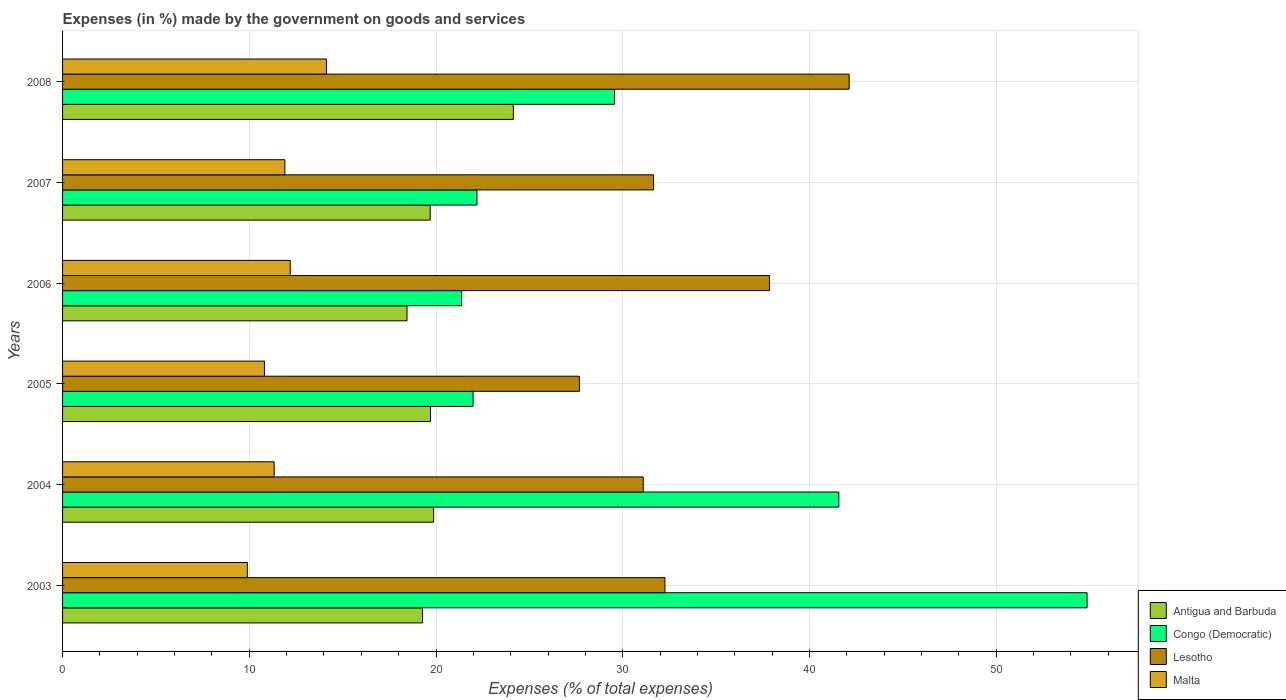How many different coloured bars are there?
Make the answer very short. 4. Are the number of bars per tick equal to the number of legend labels?
Your response must be concise. Yes. Are the number of bars on each tick of the Y-axis equal?
Your answer should be compact. Yes. In how many cases, is the number of bars for a given year not equal to the number of legend labels?
Keep it short and to the point. 0. What is the percentage of expenses made by the government on goods and services in Congo (Democratic) in 2006?
Keep it short and to the point. 21.37. Across all years, what is the maximum percentage of expenses made by the government on goods and services in Congo (Democratic)?
Ensure brevity in your answer.  54.87. Across all years, what is the minimum percentage of expenses made by the government on goods and services in Antigua and Barbuda?
Your response must be concise. 18.45. What is the total percentage of expenses made by the government on goods and services in Antigua and Barbuda in the graph?
Offer a very short reply. 121.14. What is the difference between the percentage of expenses made by the government on goods and services in Lesotho in 2007 and that in 2008?
Your answer should be very brief. -10.47. What is the difference between the percentage of expenses made by the government on goods and services in Malta in 2005 and the percentage of expenses made by the government on goods and services in Lesotho in 2008?
Your answer should be compact. -31.32. What is the average percentage of expenses made by the government on goods and services in Lesotho per year?
Provide a short and direct response. 33.78. In the year 2003, what is the difference between the percentage of expenses made by the government on goods and services in Antigua and Barbuda and percentage of expenses made by the government on goods and services in Lesotho?
Ensure brevity in your answer.  -12.98. In how many years, is the percentage of expenses made by the government on goods and services in Congo (Democratic) greater than 38 %?
Provide a short and direct response. 2. What is the ratio of the percentage of expenses made by the government on goods and services in Malta in 2005 to that in 2008?
Provide a short and direct response. 0.77. What is the difference between the highest and the second highest percentage of expenses made by the government on goods and services in Lesotho?
Make the answer very short. 4.26. What is the difference between the highest and the lowest percentage of expenses made by the government on goods and services in Congo (Democratic)?
Offer a very short reply. 33.5. In how many years, is the percentage of expenses made by the government on goods and services in Antigua and Barbuda greater than the average percentage of expenses made by the government on goods and services in Antigua and Barbuda taken over all years?
Make the answer very short. 1. Is the sum of the percentage of expenses made by the government on goods and services in Malta in 2004 and 2008 greater than the maximum percentage of expenses made by the government on goods and services in Lesotho across all years?
Make the answer very short. No. Is it the case that in every year, the sum of the percentage of expenses made by the government on goods and services in Lesotho and percentage of expenses made by the government on goods and services in Malta is greater than the sum of percentage of expenses made by the government on goods and services in Congo (Democratic) and percentage of expenses made by the government on goods and services in Antigua and Barbuda?
Make the answer very short. No. What does the 2nd bar from the top in 2007 represents?
Your answer should be compact. Lesotho. What does the 4th bar from the bottom in 2004 represents?
Your response must be concise. Malta. How many bars are there?
Give a very brief answer. 24. Are all the bars in the graph horizontal?
Give a very brief answer. Yes. How many years are there in the graph?
Your answer should be compact. 6. What is the difference between two consecutive major ticks on the X-axis?
Offer a terse response. 10. Are the values on the major ticks of X-axis written in scientific E-notation?
Provide a short and direct response. No. Does the graph contain any zero values?
Make the answer very short. No. Does the graph contain grids?
Offer a very short reply. Yes. How many legend labels are there?
Keep it short and to the point. 4. How are the legend labels stacked?
Offer a very short reply. Vertical. What is the title of the graph?
Keep it short and to the point. Expenses (in %) made by the government on goods and services. Does "European Union" appear as one of the legend labels in the graph?
Your answer should be compact. No. What is the label or title of the X-axis?
Offer a very short reply. Expenses (% of total expenses). What is the Expenses (% of total expenses) in Antigua and Barbuda in 2003?
Your answer should be compact. 19.28. What is the Expenses (% of total expenses) in Congo (Democratic) in 2003?
Your response must be concise. 54.87. What is the Expenses (% of total expenses) of Lesotho in 2003?
Keep it short and to the point. 32.26. What is the Expenses (% of total expenses) of Malta in 2003?
Your answer should be compact. 9.89. What is the Expenses (% of total expenses) in Antigua and Barbuda in 2004?
Provide a succinct answer. 19.87. What is the Expenses (% of total expenses) of Congo (Democratic) in 2004?
Offer a very short reply. 41.57. What is the Expenses (% of total expenses) of Lesotho in 2004?
Give a very brief answer. 31.1. What is the Expenses (% of total expenses) in Malta in 2004?
Offer a terse response. 11.33. What is the Expenses (% of total expenses) of Antigua and Barbuda in 2005?
Your answer should be very brief. 19.71. What is the Expenses (% of total expenses) in Congo (Democratic) in 2005?
Provide a succinct answer. 21.99. What is the Expenses (% of total expenses) in Lesotho in 2005?
Provide a short and direct response. 27.68. What is the Expenses (% of total expenses) in Malta in 2005?
Offer a terse response. 10.81. What is the Expenses (% of total expenses) in Antigua and Barbuda in 2006?
Offer a terse response. 18.45. What is the Expenses (% of total expenses) in Congo (Democratic) in 2006?
Ensure brevity in your answer.  21.37. What is the Expenses (% of total expenses) of Lesotho in 2006?
Make the answer very short. 37.86. What is the Expenses (% of total expenses) in Malta in 2006?
Ensure brevity in your answer.  12.19. What is the Expenses (% of total expenses) in Antigua and Barbuda in 2007?
Your response must be concise. 19.69. What is the Expenses (% of total expenses) of Congo (Democratic) in 2007?
Offer a very short reply. 22.19. What is the Expenses (% of total expenses) in Lesotho in 2007?
Your response must be concise. 31.65. What is the Expenses (% of total expenses) in Malta in 2007?
Your answer should be compact. 11.91. What is the Expenses (% of total expenses) of Antigua and Barbuda in 2008?
Offer a terse response. 24.14. What is the Expenses (% of total expenses) in Congo (Democratic) in 2008?
Your response must be concise. 29.56. What is the Expenses (% of total expenses) in Lesotho in 2008?
Your answer should be compact. 42.13. What is the Expenses (% of total expenses) in Malta in 2008?
Offer a very short reply. 14.13. Across all years, what is the maximum Expenses (% of total expenses) of Antigua and Barbuda?
Offer a terse response. 24.14. Across all years, what is the maximum Expenses (% of total expenses) in Congo (Democratic)?
Make the answer very short. 54.87. Across all years, what is the maximum Expenses (% of total expenses) of Lesotho?
Provide a succinct answer. 42.13. Across all years, what is the maximum Expenses (% of total expenses) in Malta?
Provide a succinct answer. 14.13. Across all years, what is the minimum Expenses (% of total expenses) in Antigua and Barbuda?
Provide a short and direct response. 18.45. Across all years, what is the minimum Expenses (% of total expenses) in Congo (Democratic)?
Keep it short and to the point. 21.37. Across all years, what is the minimum Expenses (% of total expenses) of Lesotho?
Make the answer very short. 27.68. Across all years, what is the minimum Expenses (% of total expenses) of Malta?
Keep it short and to the point. 9.89. What is the total Expenses (% of total expenses) in Antigua and Barbuda in the graph?
Offer a very short reply. 121.14. What is the total Expenses (% of total expenses) of Congo (Democratic) in the graph?
Provide a short and direct response. 191.55. What is the total Expenses (% of total expenses) of Lesotho in the graph?
Your response must be concise. 202.68. What is the total Expenses (% of total expenses) of Malta in the graph?
Make the answer very short. 70.27. What is the difference between the Expenses (% of total expenses) in Antigua and Barbuda in 2003 and that in 2004?
Your answer should be compact. -0.59. What is the difference between the Expenses (% of total expenses) of Congo (Democratic) in 2003 and that in 2004?
Your response must be concise. 13.29. What is the difference between the Expenses (% of total expenses) of Lesotho in 2003 and that in 2004?
Give a very brief answer. 1.16. What is the difference between the Expenses (% of total expenses) of Malta in 2003 and that in 2004?
Make the answer very short. -1.44. What is the difference between the Expenses (% of total expenses) of Antigua and Barbuda in 2003 and that in 2005?
Make the answer very short. -0.43. What is the difference between the Expenses (% of total expenses) of Congo (Democratic) in 2003 and that in 2005?
Keep it short and to the point. 32.88. What is the difference between the Expenses (% of total expenses) in Lesotho in 2003 and that in 2005?
Your response must be concise. 4.58. What is the difference between the Expenses (% of total expenses) in Malta in 2003 and that in 2005?
Offer a terse response. -0.92. What is the difference between the Expenses (% of total expenses) in Antigua and Barbuda in 2003 and that in 2006?
Make the answer very short. 0.83. What is the difference between the Expenses (% of total expenses) of Congo (Democratic) in 2003 and that in 2006?
Ensure brevity in your answer.  33.5. What is the difference between the Expenses (% of total expenses) of Lesotho in 2003 and that in 2006?
Make the answer very short. -5.6. What is the difference between the Expenses (% of total expenses) of Malta in 2003 and that in 2006?
Provide a succinct answer. -2.3. What is the difference between the Expenses (% of total expenses) in Antigua and Barbuda in 2003 and that in 2007?
Make the answer very short. -0.41. What is the difference between the Expenses (% of total expenses) in Congo (Democratic) in 2003 and that in 2007?
Offer a very short reply. 32.67. What is the difference between the Expenses (% of total expenses) in Lesotho in 2003 and that in 2007?
Make the answer very short. 0.61. What is the difference between the Expenses (% of total expenses) of Malta in 2003 and that in 2007?
Keep it short and to the point. -2.01. What is the difference between the Expenses (% of total expenses) in Antigua and Barbuda in 2003 and that in 2008?
Your answer should be very brief. -4.86. What is the difference between the Expenses (% of total expenses) of Congo (Democratic) in 2003 and that in 2008?
Your answer should be compact. 25.31. What is the difference between the Expenses (% of total expenses) in Lesotho in 2003 and that in 2008?
Offer a terse response. -9.87. What is the difference between the Expenses (% of total expenses) in Malta in 2003 and that in 2008?
Your answer should be very brief. -4.24. What is the difference between the Expenses (% of total expenses) in Antigua and Barbuda in 2004 and that in 2005?
Give a very brief answer. 0.17. What is the difference between the Expenses (% of total expenses) in Congo (Democratic) in 2004 and that in 2005?
Provide a short and direct response. 19.59. What is the difference between the Expenses (% of total expenses) in Lesotho in 2004 and that in 2005?
Make the answer very short. 3.42. What is the difference between the Expenses (% of total expenses) of Malta in 2004 and that in 2005?
Offer a terse response. 0.52. What is the difference between the Expenses (% of total expenses) in Antigua and Barbuda in 2004 and that in 2006?
Provide a succinct answer. 1.43. What is the difference between the Expenses (% of total expenses) of Congo (Democratic) in 2004 and that in 2006?
Provide a succinct answer. 20.2. What is the difference between the Expenses (% of total expenses) of Lesotho in 2004 and that in 2006?
Make the answer very short. -6.77. What is the difference between the Expenses (% of total expenses) of Malta in 2004 and that in 2006?
Ensure brevity in your answer.  -0.86. What is the difference between the Expenses (% of total expenses) in Antigua and Barbuda in 2004 and that in 2007?
Keep it short and to the point. 0.18. What is the difference between the Expenses (% of total expenses) of Congo (Democratic) in 2004 and that in 2007?
Keep it short and to the point. 19.38. What is the difference between the Expenses (% of total expenses) of Lesotho in 2004 and that in 2007?
Your answer should be compact. -0.56. What is the difference between the Expenses (% of total expenses) of Malta in 2004 and that in 2007?
Give a very brief answer. -0.57. What is the difference between the Expenses (% of total expenses) in Antigua and Barbuda in 2004 and that in 2008?
Your answer should be compact. -4.27. What is the difference between the Expenses (% of total expenses) in Congo (Democratic) in 2004 and that in 2008?
Make the answer very short. 12.01. What is the difference between the Expenses (% of total expenses) of Lesotho in 2004 and that in 2008?
Offer a very short reply. -11.03. What is the difference between the Expenses (% of total expenses) in Malta in 2004 and that in 2008?
Ensure brevity in your answer.  -2.8. What is the difference between the Expenses (% of total expenses) of Antigua and Barbuda in 2005 and that in 2006?
Your response must be concise. 1.26. What is the difference between the Expenses (% of total expenses) in Congo (Democratic) in 2005 and that in 2006?
Provide a short and direct response. 0.61. What is the difference between the Expenses (% of total expenses) in Lesotho in 2005 and that in 2006?
Your answer should be very brief. -10.18. What is the difference between the Expenses (% of total expenses) of Malta in 2005 and that in 2006?
Give a very brief answer. -1.38. What is the difference between the Expenses (% of total expenses) in Antigua and Barbuda in 2005 and that in 2007?
Offer a very short reply. 0.01. What is the difference between the Expenses (% of total expenses) of Congo (Democratic) in 2005 and that in 2007?
Your response must be concise. -0.21. What is the difference between the Expenses (% of total expenses) in Lesotho in 2005 and that in 2007?
Keep it short and to the point. -3.97. What is the difference between the Expenses (% of total expenses) of Malta in 2005 and that in 2007?
Give a very brief answer. -1.09. What is the difference between the Expenses (% of total expenses) of Antigua and Barbuda in 2005 and that in 2008?
Provide a short and direct response. -4.44. What is the difference between the Expenses (% of total expenses) in Congo (Democratic) in 2005 and that in 2008?
Offer a terse response. -7.58. What is the difference between the Expenses (% of total expenses) in Lesotho in 2005 and that in 2008?
Your answer should be very brief. -14.45. What is the difference between the Expenses (% of total expenses) of Malta in 2005 and that in 2008?
Your response must be concise. -3.32. What is the difference between the Expenses (% of total expenses) in Antigua and Barbuda in 2006 and that in 2007?
Your response must be concise. -1.24. What is the difference between the Expenses (% of total expenses) in Congo (Democratic) in 2006 and that in 2007?
Give a very brief answer. -0.82. What is the difference between the Expenses (% of total expenses) of Lesotho in 2006 and that in 2007?
Give a very brief answer. 6.21. What is the difference between the Expenses (% of total expenses) of Malta in 2006 and that in 2007?
Provide a short and direct response. 0.29. What is the difference between the Expenses (% of total expenses) of Antigua and Barbuda in 2006 and that in 2008?
Give a very brief answer. -5.69. What is the difference between the Expenses (% of total expenses) in Congo (Democratic) in 2006 and that in 2008?
Keep it short and to the point. -8.19. What is the difference between the Expenses (% of total expenses) in Lesotho in 2006 and that in 2008?
Your answer should be compact. -4.26. What is the difference between the Expenses (% of total expenses) of Malta in 2006 and that in 2008?
Offer a terse response. -1.94. What is the difference between the Expenses (% of total expenses) in Antigua and Barbuda in 2007 and that in 2008?
Provide a succinct answer. -4.45. What is the difference between the Expenses (% of total expenses) in Congo (Democratic) in 2007 and that in 2008?
Your answer should be very brief. -7.37. What is the difference between the Expenses (% of total expenses) of Lesotho in 2007 and that in 2008?
Offer a terse response. -10.47. What is the difference between the Expenses (% of total expenses) of Malta in 2007 and that in 2008?
Provide a succinct answer. -2.23. What is the difference between the Expenses (% of total expenses) in Antigua and Barbuda in 2003 and the Expenses (% of total expenses) in Congo (Democratic) in 2004?
Make the answer very short. -22.29. What is the difference between the Expenses (% of total expenses) in Antigua and Barbuda in 2003 and the Expenses (% of total expenses) in Lesotho in 2004?
Provide a succinct answer. -11.82. What is the difference between the Expenses (% of total expenses) in Antigua and Barbuda in 2003 and the Expenses (% of total expenses) in Malta in 2004?
Your response must be concise. 7.95. What is the difference between the Expenses (% of total expenses) of Congo (Democratic) in 2003 and the Expenses (% of total expenses) of Lesotho in 2004?
Your response must be concise. 23.77. What is the difference between the Expenses (% of total expenses) in Congo (Democratic) in 2003 and the Expenses (% of total expenses) in Malta in 2004?
Make the answer very short. 43.54. What is the difference between the Expenses (% of total expenses) in Lesotho in 2003 and the Expenses (% of total expenses) in Malta in 2004?
Give a very brief answer. 20.93. What is the difference between the Expenses (% of total expenses) in Antigua and Barbuda in 2003 and the Expenses (% of total expenses) in Congo (Democratic) in 2005?
Give a very brief answer. -2.71. What is the difference between the Expenses (% of total expenses) in Antigua and Barbuda in 2003 and the Expenses (% of total expenses) in Lesotho in 2005?
Keep it short and to the point. -8.4. What is the difference between the Expenses (% of total expenses) of Antigua and Barbuda in 2003 and the Expenses (% of total expenses) of Malta in 2005?
Make the answer very short. 8.47. What is the difference between the Expenses (% of total expenses) in Congo (Democratic) in 2003 and the Expenses (% of total expenses) in Lesotho in 2005?
Offer a terse response. 27.19. What is the difference between the Expenses (% of total expenses) in Congo (Democratic) in 2003 and the Expenses (% of total expenses) in Malta in 2005?
Make the answer very short. 44.06. What is the difference between the Expenses (% of total expenses) in Lesotho in 2003 and the Expenses (% of total expenses) in Malta in 2005?
Provide a succinct answer. 21.45. What is the difference between the Expenses (% of total expenses) in Antigua and Barbuda in 2003 and the Expenses (% of total expenses) in Congo (Democratic) in 2006?
Give a very brief answer. -2.09. What is the difference between the Expenses (% of total expenses) of Antigua and Barbuda in 2003 and the Expenses (% of total expenses) of Lesotho in 2006?
Give a very brief answer. -18.58. What is the difference between the Expenses (% of total expenses) of Antigua and Barbuda in 2003 and the Expenses (% of total expenses) of Malta in 2006?
Your response must be concise. 7.09. What is the difference between the Expenses (% of total expenses) of Congo (Democratic) in 2003 and the Expenses (% of total expenses) of Lesotho in 2006?
Offer a terse response. 17.01. What is the difference between the Expenses (% of total expenses) of Congo (Democratic) in 2003 and the Expenses (% of total expenses) of Malta in 2006?
Make the answer very short. 42.67. What is the difference between the Expenses (% of total expenses) of Lesotho in 2003 and the Expenses (% of total expenses) of Malta in 2006?
Provide a short and direct response. 20.07. What is the difference between the Expenses (% of total expenses) of Antigua and Barbuda in 2003 and the Expenses (% of total expenses) of Congo (Democratic) in 2007?
Your response must be concise. -2.91. What is the difference between the Expenses (% of total expenses) of Antigua and Barbuda in 2003 and the Expenses (% of total expenses) of Lesotho in 2007?
Provide a short and direct response. -12.37. What is the difference between the Expenses (% of total expenses) of Antigua and Barbuda in 2003 and the Expenses (% of total expenses) of Malta in 2007?
Offer a very short reply. 7.38. What is the difference between the Expenses (% of total expenses) of Congo (Democratic) in 2003 and the Expenses (% of total expenses) of Lesotho in 2007?
Provide a succinct answer. 23.21. What is the difference between the Expenses (% of total expenses) in Congo (Democratic) in 2003 and the Expenses (% of total expenses) in Malta in 2007?
Ensure brevity in your answer.  42.96. What is the difference between the Expenses (% of total expenses) in Lesotho in 2003 and the Expenses (% of total expenses) in Malta in 2007?
Your response must be concise. 20.36. What is the difference between the Expenses (% of total expenses) in Antigua and Barbuda in 2003 and the Expenses (% of total expenses) in Congo (Democratic) in 2008?
Your answer should be compact. -10.28. What is the difference between the Expenses (% of total expenses) of Antigua and Barbuda in 2003 and the Expenses (% of total expenses) of Lesotho in 2008?
Your response must be concise. -22.85. What is the difference between the Expenses (% of total expenses) of Antigua and Barbuda in 2003 and the Expenses (% of total expenses) of Malta in 2008?
Provide a short and direct response. 5.15. What is the difference between the Expenses (% of total expenses) of Congo (Democratic) in 2003 and the Expenses (% of total expenses) of Lesotho in 2008?
Provide a succinct answer. 12.74. What is the difference between the Expenses (% of total expenses) of Congo (Democratic) in 2003 and the Expenses (% of total expenses) of Malta in 2008?
Provide a succinct answer. 40.74. What is the difference between the Expenses (% of total expenses) in Lesotho in 2003 and the Expenses (% of total expenses) in Malta in 2008?
Provide a succinct answer. 18.13. What is the difference between the Expenses (% of total expenses) in Antigua and Barbuda in 2004 and the Expenses (% of total expenses) in Congo (Democratic) in 2005?
Ensure brevity in your answer.  -2.11. What is the difference between the Expenses (% of total expenses) in Antigua and Barbuda in 2004 and the Expenses (% of total expenses) in Lesotho in 2005?
Offer a terse response. -7.81. What is the difference between the Expenses (% of total expenses) in Antigua and Barbuda in 2004 and the Expenses (% of total expenses) in Malta in 2005?
Provide a short and direct response. 9.06. What is the difference between the Expenses (% of total expenses) in Congo (Democratic) in 2004 and the Expenses (% of total expenses) in Lesotho in 2005?
Your answer should be compact. 13.89. What is the difference between the Expenses (% of total expenses) in Congo (Democratic) in 2004 and the Expenses (% of total expenses) in Malta in 2005?
Your answer should be compact. 30.76. What is the difference between the Expenses (% of total expenses) of Lesotho in 2004 and the Expenses (% of total expenses) of Malta in 2005?
Offer a terse response. 20.29. What is the difference between the Expenses (% of total expenses) of Antigua and Barbuda in 2004 and the Expenses (% of total expenses) of Congo (Democratic) in 2006?
Keep it short and to the point. -1.5. What is the difference between the Expenses (% of total expenses) of Antigua and Barbuda in 2004 and the Expenses (% of total expenses) of Lesotho in 2006?
Offer a very short reply. -17.99. What is the difference between the Expenses (% of total expenses) of Antigua and Barbuda in 2004 and the Expenses (% of total expenses) of Malta in 2006?
Provide a succinct answer. 7.68. What is the difference between the Expenses (% of total expenses) in Congo (Democratic) in 2004 and the Expenses (% of total expenses) in Lesotho in 2006?
Your answer should be compact. 3.71. What is the difference between the Expenses (% of total expenses) of Congo (Democratic) in 2004 and the Expenses (% of total expenses) of Malta in 2006?
Your response must be concise. 29.38. What is the difference between the Expenses (% of total expenses) of Lesotho in 2004 and the Expenses (% of total expenses) of Malta in 2006?
Make the answer very short. 18.9. What is the difference between the Expenses (% of total expenses) in Antigua and Barbuda in 2004 and the Expenses (% of total expenses) in Congo (Democratic) in 2007?
Your response must be concise. -2.32. What is the difference between the Expenses (% of total expenses) in Antigua and Barbuda in 2004 and the Expenses (% of total expenses) in Lesotho in 2007?
Ensure brevity in your answer.  -11.78. What is the difference between the Expenses (% of total expenses) of Antigua and Barbuda in 2004 and the Expenses (% of total expenses) of Malta in 2007?
Offer a very short reply. 7.97. What is the difference between the Expenses (% of total expenses) of Congo (Democratic) in 2004 and the Expenses (% of total expenses) of Lesotho in 2007?
Offer a very short reply. 9.92. What is the difference between the Expenses (% of total expenses) in Congo (Democratic) in 2004 and the Expenses (% of total expenses) in Malta in 2007?
Your answer should be compact. 29.67. What is the difference between the Expenses (% of total expenses) of Lesotho in 2004 and the Expenses (% of total expenses) of Malta in 2007?
Offer a very short reply. 19.19. What is the difference between the Expenses (% of total expenses) of Antigua and Barbuda in 2004 and the Expenses (% of total expenses) of Congo (Democratic) in 2008?
Provide a succinct answer. -9.69. What is the difference between the Expenses (% of total expenses) of Antigua and Barbuda in 2004 and the Expenses (% of total expenses) of Lesotho in 2008?
Give a very brief answer. -22.25. What is the difference between the Expenses (% of total expenses) of Antigua and Barbuda in 2004 and the Expenses (% of total expenses) of Malta in 2008?
Ensure brevity in your answer.  5.74. What is the difference between the Expenses (% of total expenses) of Congo (Democratic) in 2004 and the Expenses (% of total expenses) of Lesotho in 2008?
Provide a succinct answer. -0.55. What is the difference between the Expenses (% of total expenses) in Congo (Democratic) in 2004 and the Expenses (% of total expenses) in Malta in 2008?
Offer a terse response. 27.44. What is the difference between the Expenses (% of total expenses) in Lesotho in 2004 and the Expenses (% of total expenses) in Malta in 2008?
Your answer should be compact. 16.97. What is the difference between the Expenses (% of total expenses) in Antigua and Barbuda in 2005 and the Expenses (% of total expenses) in Congo (Democratic) in 2006?
Ensure brevity in your answer.  -1.67. What is the difference between the Expenses (% of total expenses) in Antigua and Barbuda in 2005 and the Expenses (% of total expenses) in Lesotho in 2006?
Provide a short and direct response. -18.16. What is the difference between the Expenses (% of total expenses) in Antigua and Barbuda in 2005 and the Expenses (% of total expenses) in Malta in 2006?
Provide a short and direct response. 7.51. What is the difference between the Expenses (% of total expenses) in Congo (Democratic) in 2005 and the Expenses (% of total expenses) in Lesotho in 2006?
Make the answer very short. -15.88. What is the difference between the Expenses (% of total expenses) of Congo (Democratic) in 2005 and the Expenses (% of total expenses) of Malta in 2006?
Your answer should be very brief. 9.79. What is the difference between the Expenses (% of total expenses) of Lesotho in 2005 and the Expenses (% of total expenses) of Malta in 2006?
Give a very brief answer. 15.49. What is the difference between the Expenses (% of total expenses) of Antigua and Barbuda in 2005 and the Expenses (% of total expenses) of Congo (Democratic) in 2007?
Provide a succinct answer. -2.49. What is the difference between the Expenses (% of total expenses) in Antigua and Barbuda in 2005 and the Expenses (% of total expenses) in Lesotho in 2007?
Your response must be concise. -11.95. What is the difference between the Expenses (% of total expenses) in Antigua and Barbuda in 2005 and the Expenses (% of total expenses) in Malta in 2007?
Offer a terse response. 7.8. What is the difference between the Expenses (% of total expenses) in Congo (Democratic) in 2005 and the Expenses (% of total expenses) in Lesotho in 2007?
Offer a very short reply. -9.67. What is the difference between the Expenses (% of total expenses) in Congo (Democratic) in 2005 and the Expenses (% of total expenses) in Malta in 2007?
Offer a very short reply. 10.08. What is the difference between the Expenses (% of total expenses) in Lesotho in 2005 and the Expenses (% of total expenses) in Malta in 2007?
Provide a succinct answer. 15.78. What is the difference between the Expenses (% of total expenses) of Antigua and Barbuda in 2005 and the Expenses (% of total expenses) of Congo (Democratic) in 2008?
Your response must be concise. -9.86. What is the difference between the Expenses (% of total expenses) in Antigua and Barbuda in 2005 and the Expenses (% of total expenses) in Lesotho in 2008?
Provide a short and direct response. -22.42. What is the difference between the Expenses (% of total expenses) of Antigua and Barbuda in 2005 and the Expenses (% of total expenses) of Malta in 2008?
Ensure brevity in your answer.  5.57. What is the difference between the Expenses (% of total expenses) of Congo (Democratic) in 2005 and the Expenses (% of total expenses) of Lesotho in 2008?
Keep it short and to the point. -20.14. What is the difference between the Expenses (% of total expenses) of Congo (Democratic) in 2005 and the Expenses (% of total expenses) of Malta in 2008?
Your answer should be very brief. 7.85. What is the difference between the Expenses (% of total expenses) of Lesotho in 2005 and the Expenses (% of total expenses) of Malta in 2008?
Your answer should be compact. 13.55. What is the difference between the Expenses (% of total expenses) in Antigua and Barbuda in 2006 and the Expenses (% of total expenses) in Congo (Democratic) in 2007?
Give a very brief answer. -3.75. What is the difference between the Expenses (% of total expenses) of Antigua and Barbuda in 2006 and the Expenses (% of total expenses) of Lesotho in 2007?
Give a very brief answer. -13.21. What is the difference between the Expenses (% of total expenses) of Antigua and Barbuda in 2006 and the Expenses (% of total expenses) of Malta in 2007?
Offer a terse response. 6.54. What is the difference between the Expenses (% of total expenses) in Congo (Democratic) in 2006 and the Expenses (% of total expenses) in Lesotho in 2007?
Offer a terse response. -10.28. What is the difference between the Expenses (% of total expenses) of Congo (Democratic) in 2006 and the Expenses (% of total expenses) of Malta in 2007?
Ensure brevity in your answer.  9.47. What is the difference between the Expenses (% of total expenses) of Lesotho in 2006 and the Expenses (% of total expenses) of Malta in 2007?
Your answer should be compact. 25.96. What is the difference between the Expenses (% of total expenses) in Antigua and Barbuda in 2006 and the Expenses (% of total expenses) in Congo (Democratic) in 2008?
Ensure brevity in your answer.  -11.11. What is the difference between the Expenses (% of total expenses) of Antigua and Barbuda in 2006 and the Expenses (% of total expenses) of Lesotho in 2008?
Offer a very short reply. -23.68. What is the difference between the Expenses (% of total expenses) of Antigua and Barbuda in 2006 and the Expenses (% of total expenses) of Malta in 2008?
Give a very brief answer. 4.32. What is the difference between the Expenses (% of total expenses) of Congo (Democratic) in 2006 and the Expenses (% of total expenses) of Lesotho in 2008?
Make the answer very short. -20.76. What is the difference between the Expenses (% of total expenses) of Congo (Democratic) in 2006 and the Expenses (% of total expenses) of Malta in 2008?
Keep it short and to the point. 7.24. What is the difference between the Expenses (% of total expenses) in Lesotho in 2006 and the Expenses (% of total expenses) in Malta in 2008?
Offer a terse response. 23.73. What is the difference between the Expenses (% of total expenses) in Antigua and Barbuda in 2007 and the Expenses (% of total expenses) in Congo (Democratic) in 2008?
Your answer should be very brief. -9.87. What is the difference between the Expenses (% of total expenses) of Antigua and Barbuda in 2007 and the Expenses (% of total expenses) of Lesotho in 2008?
Your answer should be compact. -22.44. What is the difference between the Expenses (% of total expenses) in Antigua and Barbuda in 2007 and the Expenses (% of total expenses) in Malta in 2008?
Provide a short and direct response. 5.56. What is the difference between the Expenses (% of total expenses) in Congo (Democratic) in 2007 and the Expenses (% of total expenses) in Lesotho in 2008?
Keep it short and to the point. -19.93. What is the difference between the Expenses (% of total expenses) of Congo (Democratic) in 2007 and the Expenses (% of total expenses) of Malta in 2008?
Your answer should be compact. 8.06. What is the difference between the Expenses (% of total expenses) in Lesotho in 2007 and the Expenses (% of total expenses) in Malta in 2008?
Provide a short and direct response. 17.52. What is the average Expenses (% of total expenses) of Antigua and Barbuda per year?
Give a very brief answer. 20.19. What is the average Expenses (% of total expenses) of Congo (Democratic) per year?
Your answer should be compact. 31.93. What is the average Expenses (% of total expenses) of Lesotho per year?
Make the answer very short. 33.78. What is the average Expenses (% of total expenses) in Malta per year?
Provide a succinct answer. 11.71. In the year 2003, what is the difference between the Expenses (% of total expenses) in Antigua and Barbuda and Expenses (% of total expenses) in Congo (Democratic)?
Provide a short and direct response. -35.59. In the year 2003, what is the difference between the Expenses (% of total expenses) in Antigua and Barbuda and Expenses (% of total expenses) in Lesotho?
Offer a terse response. -12.98. In the year 2003, what is the difference between the Expenses (% of total expenses) of Antigua and Barbuda and Expenses (% of total expenses) of Malta?
Provide a short and direct response. 9.39. In the year 2003, what is the difference between the Expenses (% of total expenses) of Congo (Democratic) and Expenses (% of total expenses) of Lesotho?
Offer a very short reply. 22.61. In the year 2003, what is the difference between the Expenses (% of total expenses) of Congo (Democratic) and Expenses (% of total expenses) of Malta?
Your answer should be compact. 44.97. In the year 2003, what is the difference between the Expenses (% of total expenses) in Lesotho and Expenses (% of total expenses) in Malta?
Provide a succinct answer. 22.37. In the year 2004, what is the difference between the Expenses (% of total expenses) of Antigua and Barbuda and Expenses (% of total expenses) of Congo (Democratic)?
Offer a terse response. -21.7. In the year 2004, what is the difference between the Expenses (% of total expenses) in Antigua and Barbuda and Expenses (% of total expenses) in Lesotho?
Ensure brevity in your answer.  -11.22. In the year 2004, what is the difference between the Expenses (% of total expenses) of Antigua and Barbuda and Expenses (% of total expenses) of Malta?
Offer a very short reply. 8.54. In the year 2004, what is the difference between the Expenses (% of total expenses) in Congo (Democratic) and Expenses (% of total expenses) in Lesotho?
Make the answer very short. 10.48. In the year 2004, what is the difference between the Expenses (% of total expenses) of Congo (Democratic) and Expenses (% of total expenses) of Malta?
Keep it short and to the point. 30.24. In the year 2004, what is the difference between the Expenses (% of total expenses) in Lesotho and Expenses (% of total expenses) in Malta?
Give a very brief answer. 19.77. In the year 2005, what is the difference between the Expenses (% of total expenses) in Antigua and Barbuda and Expenses (% of total expenses) in Congo (Democratic)?
Offer a very short reply. -2.28. In the year 2005, what is the difference between the Expenses (% of total expenses) of Antigua and Barbuda and Expenses (% of total expenses) of Lesotho?
Offer a terse response. -7.98. In the year 2005, what is the difference between the Expenses (% of total expenses) of Antigua and Barbuda and Expenses (% of total expenses) of Malta?
Offer a very short reply. 8.89. In the year 2005, what is the difference between the Expenses (% of total expenses) of Congo (Democratic) and Expenses (% of total expenses) of Lesotho?
Offer a terse response. -5.7. In the year 2005, what is the difference between the Expenses (% of total expenses) in Congo (Democratic) and Expenses (% of total expenses) in Malta?
Your response must be concise. 11.17. In the year 2005, what is the difference between the Expenses (% of total expenses) in Lesotho and Expenses (% of total expenses) in Malta?
Your answer should be compact. 16.87. In the year 2006, what is the difference between the Expenses (% of total expenses) in Antigua and Barbuda and Expenses (% of total expenses) in Congo (Democratic)?
Your response must be concise. -2.92. In the year 2006, what is the difference between the Expenses (% of total expenses) in Antigua and Barbuda and Expenses (% of total expenses) in Lesotho?
Your answer should be very brief. -19.42. In the year 2006, what is the difference between the Expenses (% of total expenses) in Antigua and Barbuda and Expenses (% of total expenses) in Malta?
Ensure brevity in your answer.  6.25. In the year 2006, what is the difference between the Expenses (% of total expenses) in Congo (Democratic) and Expenses (% of total expenses) in Lesotho?
Ensure brevity in your answer.  -16.49. In the year 2006, what is the difference between the Expenses (% of total expenses) of Congo (Democratic) and Expenses (% of total expenses) of Malta?
Make the answer very short. 9.18. In the year 2006, what is the difference between the Expenses (% of total expenses) of Lesotho and Expenses (% of total expenses) of Malta?
Provide a succinct answer. 25.67. In the year 2007, what is the difference between the Expenses (% of total expenses) in Antigua and Barbuda and Expenses (% of total expenses) in Congo (Democratic)?
Offer a very short reply. -2.5. In the year 2007, what is the difference between the Expenses (% of total expenses) in Antigua and Barbuda and Expenses (% of total expenses) in Lesotho?
Give a very brief answer. -11.96. In the year 2007, what is the difference between the Expenses (% of total expenses) of Antigua and Barbuda and Expenses (% of total expenses) of Malta?
Your answer should be compact. 7.79. In the year 2007, what is the difference between the Expenses (% of total expenses) in Congo (Democratic) and Expenses (% of total expenses) in Lesotho?
Offer a terse response. -9.46. In the year 2007, what is the difference between the Expenses (% of total expenses) of Congo (Democratic) and Expenses (% of total expenses) of Malta?
Provide a succinct answer. 10.29. In the year 2007, what is the difference between the Expenses (% of total expenses) of Lesotho and Expenses (% of total expenses) of Malta?
Your response must be concise. 19.75. In the year 2008, what is the difference between the Expenses (% of total expenses) of Antigua and Barbuda and Expenses (% of total expenses) of Congo (Democratic)?
Your answer should be very brief. -5.42. In the year 2008, what is the difference between the Expenses (% of total expenses) of Antigua and Barbuda and Expenses (% of total expenses) of Lesotho?
Your answer should be very brief. -17.99. In the year 2008, what is the difference between the Expenses (% of total expenses) of Antigua and Barbuda and Expenses (% of total expenses) of Malta?
Provide a short and direct response. 10.01. In the year 2008, what is the difference between the Expenses (% of total expenses) of Congo (Democratic) and Expenses (% of total expenses) of Lesotho?
Offer a very short reply. -12.57. In the year 2008, what is the difference between the Expenses (% of total expenses) of Congo (Democratic) and Expenses (% of total expenses) of Malta?
Your answer should be compact. 15.43. In the year 2008, what is the difference between the Expenses (% of total expenses) of Lesotho and Expenses (% of total expenses) of Malta?
Offer a terse response. 28. What is the ratio of the Expenses (% of total expenses) in Antigua and Barbuda in 2003 to that in 2004?
Offer a very short reply. 0.97. What is the ratio of the Expenses (% of total expenses) in Congo (Democratic) in 2003 to that in 2004?
Your answer should be compact. 1.32. What is the ratio of the Expenses (% of total expenses) in Lesotho in 2003 to that in 2004?
Make the answer very short. 1.04. What is the ratio of the Expenses (% of total expenses) of Malta in 2003 to that in 2004?
Make the answer very short. 0.87. What is the ratio of the Expenses (% of total expenses) of Antigua and Barbuda in 2003 to that in 2005?
Make the answer very short. 0.98. What is the ratio of the Expenses (% of total expenses) of Congo (Democratic) in 2003 to that in 2005?
Your response must be concise. 2.5. What is the ratio of the Expenses (% of total expenses) of Lesotho in 2003 to that in 2005?
Offer a very short reply. 1.17. What is the ratio of the Expenses (% of total expenses) in Malta in 2003 to that in 2005?
Provide a short and direct response. 0.92. What is the ratio of the Expenses (% of total expenses) in Antigua and Barbuda in 2003 to that in 2006?
Your response must be concise. 1.05. What is the ratio of the Expenses (% of total expenses) in Congo (Democratic) in 2003 to that in 2006?
Your answer should be very brief. 2.57. What is the ratio of the Expenses (% of total expenses) of Lesotho in 2003 to that in 2006?
Your answer should be compact. 0.85. What is the ratio of the Expenses (% of total expenses) of Malta in 2003 to that in 2006?
Provide a succinct answer. 0.81. What is the ratio of the Expenses (% of total expenses) in Antigua and Barbuda in 2003 to that in 2007?
Provide a succinct answer. 0.98. What is the ratio of the Expenses (% of total expenses) of Congo (Democratic) in 2003 to that in 2007?
Ensure brevity in your answer.  2.47. What is the ratio of the Expenses (% of total expenses) in Lesotho in 2003 to that in 2007?
Your response must be concise. 1.02. What is the ratio of the Expenses (% of total expenses) in Malta in 2003 to that in 2007?
Provide a short and direct response. 0.83. What is the ratio of the Expenses (% of total expenses) of Antigua and Barbuda in 2003 to that in 2008?
Your answer should be compact. 0.8. What is the ratio of the Expenses (% of total expenses) of Congo (Democratic) in 2003 to that in 2008?
Your answer should be very brief. 1.86. What is the ratio of the Expenses (% of total expenses) of Lesotho in 2003 to that in 2008?
Your answer should be very brief. 0.77. What is the ratio of the Expenses (% of total expenses) in Malta in 2003 to that in 2008?
Your answer should be compact. 0.7. What is the ratio of the Expenses (% of total expenses) of Antigua and Barbuda in 2004 to that in 2005?
Your answer should be very brief. 1.01. What is the ratio of the Expenses (% of total expenses) of Congo (Democratic) in 2004 to that in 2005?
Provide a short and direct response. 1.89. What is the ratio of the Expenses (% of total expenses) in Lesotho in 2004 to that in 2005?
Keep it short and to the point. 1.12. What is the ratio of the Expenses (% of total expenses) in Malta in 2004 to that in 2005?
Provide a short and direct response. 1.05. What is the ratio of the Expenses (% of total expenses) of Antigua and Barbuda in 2004 to that in 2006?
Offer a very short reply. 1.08. What is the ratio of the Expenses (% of total expenses) in Congo (Democratic) in 2004 to that in 2006?
Offer a very short reply. 1.95. What is the ratio of the Expenses (% of total expenses) of Lesotho in 2004 to that in 2006?
Ensure brevity in your answer.  0.82. What is the ratio of the Expenses (% of total expenses) of Malta in 2004 to that in 2006?
Give a very brief answer. 0.93. What is the ratio of the Expenses (% of total expenses) of Antigua and Barbuda in 2004 to that in 2007?
Provide a succinct answer. 1.01. What is the ratio of the Expenses (% of total expenses) of Congo (Democratic) in 2004 to that in 2007?
Offer a terse response. 1.87. What is the ratio of the Expenses (% of total expenses) of Lesotho in 2004 to that in 2007?
Offer a very short reply. 0.98. What is the ratio of the Expenses (% of total expenses) of Malta in 2004 to that in 2007?
Provide a short and direct response. 0.95. What is the ratio of the Expenses (% of total expenses) in Antigua and Barbuda in 2004 to that in 2008?
Your response must be concise. 0.82. What is the ratio of the Expenses (% of total expenses) in Congo (Democratic) in 2004 to that in 2008?
Offer a very short reply. 1.41. What is the ratio of the Expenses (% of total expenses) of Lesotho in 2004 to that in 2008?
Make the answer very short. 0.74. What is the ratio of the Expenses (% of total expenses) of Malta in 2004 to that in 2008?
Provide a succinct answer. 0.8. What is the ratio of the Expenses (% of total expenses) of Antigua and Barbuda in 2005 to that in 2006?
Offer a terse response. 1.07. What is the ratio of the Expenses (% of total expenses) of Congo (Democratic) in 2005 to that in 2006?
Your answer should be very brief. 1.03. What is the ratio of the Expenses (% of total expenses) in Lesotho in 2005 to that in 2006?
Your answer should be compact. 0.73. What is the ratio of the Expenses (% of total expenses) of Malta in 2005 to that in 2006?
Give a very brief answer. 0.89. What is the ratio of the Expenses (% of total expenses) of Congo (Democratic) in 2005 to that in 2007?
Provide a succinct answer. 0.99. What is the ratio of the Expenses (% of total expenses) of Lesotho in 2005 to that in 2007?
Give a very brief answer. 0.87. What is the ratio of the Expenses (% of total expenses) in Malta in 2005 to that in 2007?
Ensure brevity in your answer.  0.91. What is the ratio of the Expenses (% of total expenses) in Antigua and Barbuda in 2005 to that in 2008?
Your answer should be very brief. 0.82. What is the ratio of the Expenses (% of total expenses) of Congo (Democratic) in 2005 to that in 2008?
Make the answer very short. 0.74. What is the ratio of the Expenses (% of total expenses) of Lesotho in 2005 to that in 2008?
Provide a succinct answer. 0.66. What is the ratio of the Expenses (% of total expenses) in Malta in 2005 to that in 2008?
Give a very brief answer. 0.77. What is the ratio of the Expenses (% of total expenses) in Antigua and Barbuda in 2006 to that in 2007?
Keep it short and to the point. 0.94. What is the ratio of the Expenses (% of total expenses) in Lesotho in 2006 to that in 2007?
Ensure brevity in your answer.  1.2. What is the ratio of the Expenses (% of total expenses) in Malta in 2006 to that in 2007?
Provide a succinct answer. 1.02. What is the ratio of the Expenses (% of total expenses) in Antigua and Barbuda in 2006 to that in 2008?
Keep it short and to the point. 0.76. What is the ratio of the Expenses (% of total expenses) in Congo (Democratic) in 2006 to that in 2008?
Offer a very short reply. 0.72. What is the ratio of the Expenses (% of total expenses) of Lesotho in 2006 to that in 2008?
Provide a short and direct response. 0.9. What is the ratio of the Expenses (% of total expenses) of Malta in 2006 to that in 2008?
Give a very brief answer. 0.86. What is the ratio of the Expenses (% of total expenses) in Antigua and Barbuda in 2007 to that in 2008?
Ensure brevity in your answer.  0.82. What is the ratio of the Expenses (% of total expenses) in Congo (Democratic) in 2007 to that in 2008?
Offer a very short reply. 0.75. What is the ratio of the Expenses (% of total expenses) of Lesotho in 2007 to that in 2008?
Offer a very short reply. 0.75. What is the ratio of the Expenses (% of total expenses) of Malta in 2007 to that in 2008?
Make the answer very short. 0.84. What is the difference between the highest and the second highest Expenses (% of total expenses) of Antigua and Barbuda?
Make the answer very short. 4.27. What is the difference between the highest and the second highest Expenses (% of total expenses) in Congo (Democratic)?
Ensure brevity in your answer.  13.29. What is the difference between the highest and the second highest Expenses (% of total expenses) of Lesotho?
Ensure brevity in your answer.  4.26. What is the difference between the highest and the second highest Expenses (% of total expenses) of Malta?
Make the answer very short. 1.94. What is the difference between the highest and the lowest Expenses (% of total expenses) of Antigua and Barbuda?
Provide a short and direct response. 5.69. What is the difference between the highest and the lowest Expenses (% of total expenses) of Congo (Democratic)?
Your response must be concise. 33.5. What is the difference between the highest and the lowest Expenses (% of total expenses) of Lesotho?
Offer a terse response. 14.45. What is the difference between the highest and the lowest Expenses (% of total expenses) in Malta?
Ensure brevity in your answer.  4.24. 